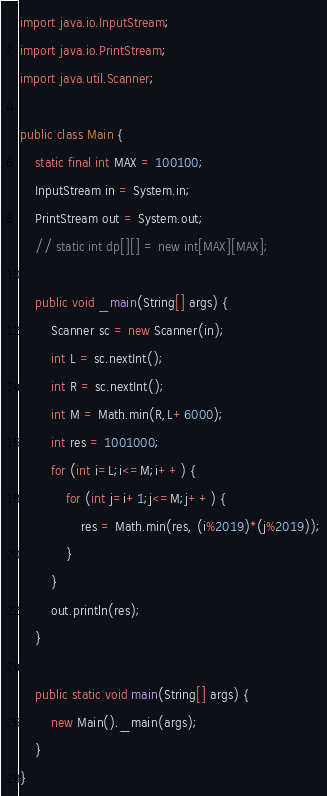Convert code to text. <code><loc_0><loc_0><loc_500><loc_500><_Java_>import java.io.InputStream;
import java.io.PrintStream;
import java.util.Scanner;

public class Main {
    static final int MAX = 100100;
    InputStream in = System.in;
    PrintStream out = System.out;
    // static int dp[][] = new int[MAX][MAX];

    public void _main(String[] args) {
        Scanner sc = new Scanner(in);
        int L = sc.nextInt();
        int R = sc.nextInt();
        int M = Math.min(R,L+6000);
        int res = 1001000;
        for (int i=L;i<=M;i++) {
            for (int j=i+1;j<=M;j++) {
                res = Math.min(res, (i%2019)*(j%2019));
            }
        }
        out.println(res);
    }

    public static void main(String[] args) {
        new Main()._main(args);
    }
}
</code> 